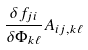<formula> <loc_0><loc_0><loc_500><loc_500>\frac { \delta f _ { j i } } { \delta \Phi _ { k \ell } } A _ { i j , k \ell }</formula> 